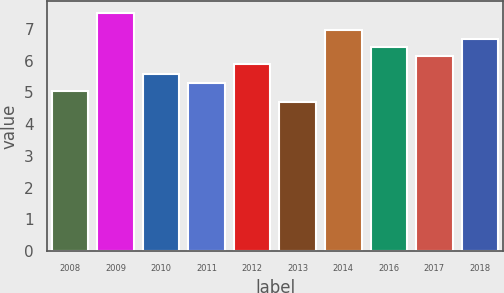Convert chart to OTSL. <chart><loc_0><loc_0><loc_500><loc_500><bar_chart><fcel>2008<fcel>2009<fcel>2010<fcel>2011<fcel>2012<fcel>2013<fcel>2014<fcel>2016<fcel>2017<fcel>2018<nl><fcel>5.04<fcel>7.51<fcel>5.58<fcel>5.31<fcel>5.89<fcel>4.71<fcel>6.97<fcel>6.43<fcel>6.16<fcel>6.7<nl></chart> 